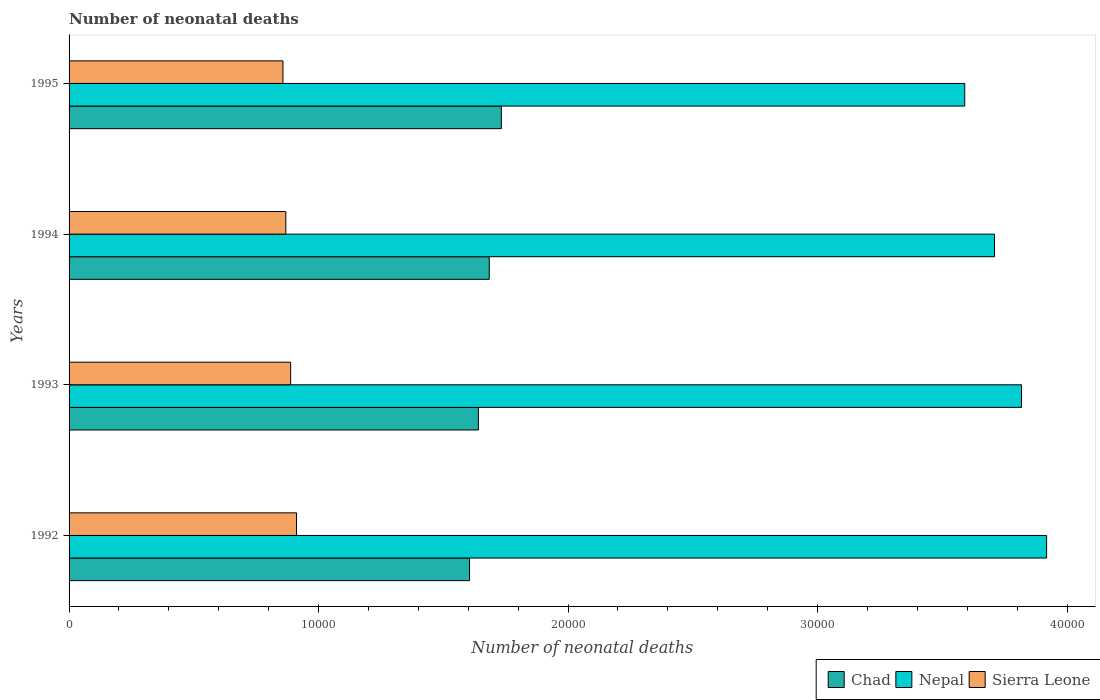How many different coloured bars are there?
Make the answer very short. 3. How many groups of bars are there?
Your answer should be very brief. 4. How many bars are there on the 4th tick from the top?
Provide a short and direct response. 3. In how many cases, is the number of bars for a given year not equal to the number of legend labels?
Your answer should be very brief. 0. What is the number of neonatal deaths in in Sierra Leone in 1993?
Give a very brief answer. 8881. Across all years, what is the maximum number of neonatal deaths in in Chad?
Make the answer very short. 1.73e+04. Across all years, what is the minimum number of neonatal deaths in in Chad?
Offer a very short reply. 1.60e+04. In which year was the number of neonatal deaths in in Sierra Leone maximum?
Give a very brief answer. 1992. What is the total number of neonatal deaths in in Nepal in the graph?
Ensure brevity in your answer.  1.50e+05. What is the difference between the number of neonatal deaths in in Nepal in 1992 and that in 1993?
Keep it short and to the point. 1006. What is the difference between the number of neonatal deaths in in Nepal in 1993 and the number of neonatal deaths in in Sierra Leone in 1995?
Your answer should be compact. 2.96e+04. What is the average number of neonatal deaths in in Chad per year?
Offer a very short reply. 1.67e+04. In the year 1992, what is the difference between the number of neonatal deaths in in Sierra Leone and number of neonatal deaths in in Nepal?
Provide a succinct answer. -3.01e+04. What is the ratio of the number of neonatal deaths in in Chad in 1992 to that in 1993?
Provide a succinct answer. 0.98. What is the difference between the highest and the second highest number of neonatal deaths in in Nepal?
Keep it short and to the point. 1006. What is the difference between the highest and the lowest number of neonatal deaths in in Chad?
Keep it short and to the point. 1275. In how many years, is the number of neonatal deaths in in Chad greater than the average number of neonatal deaths in in Chad taken over all years?
Your answer should be compact. 2. What does the 2nd bar from the top in 1993 represents?
Your response must be concise. Nepal. What does the 3rd bar from the bottom in 1993 represents?
Your response must be concise. Sierra Leone. Is it the case that in every year, the sum of the number of neonatal deaths in in Sierra Leone and number of neonatal deaths in in Chad is greater than the number of neonatal deaths in in Nepal?
Ensure brevity in your answer.  No. How many bars are there?
Provide a succinct answer. 12. Are all the bars in the graph horizontal?
Provide a succinct answer. Yes. How many years are there in the graph?
Give a very brief answer. 4. What is the difference between two consecutive major ticks on the X-axis?
Ensure brevity in your answer.  10000. Are the values on the major ticks of X-axis written in scientific E-notation?
Provide a short and direct response. No. Does the graph contain any zero values?
Offer a very short reply. No. Does the graph contain grids?
Your answer should be very brief. No. Where does the legend appear in the graph?
Your answer should be compact. Bottom right. How many legend labels are there?
Give a very brief answer. 3. How are the legend labels stacked?
Keep it short and to the point. Horizontal. What is the title of the graph?
Offer a very short reply. Number of neonatal deaths. What is the label or title of the X-axis?
Ensure brevity in your answer.  Number of neonatal deaths. What is the Number of neonatal deaths of Chad in 1992?
Your response must be concise. 1.60e+04. What is the Number of neonatal deaths in Nepal in 1992?
Keep it short and to the point. 3.92e+04. What is the Number of neonatal deaths in Sierra Leone in 1992?
Make the answer very short. 9116. What is the Number of neonatal deaths in Chad in 1993?
Your response must be concise. 1.64e+04. What is the Number of neonatal deaths in Nepal in 1993?
Ensure brevity in your answer.  3.82e+04. What is the Number of neonatal deaths in Sierra Leone in 1993?
Offer a very short reply. 8881. What is the Number of neonatal deaths in Chad in 1994?
Your answer should be very brief. 1.68e+04. What is the Number of neonatal deaths of Nepal in 1994?
Provide a succinct answer. 3.71e+04. What is the Number of neonatal deaths in Sierra Leone in 1994?
Your answer should be very brief. 8688. What is the Number of neonatal deaths in Chad in 1995?
Your response must be concise. 1.73e+04. What is the Number of neonatal deaths in Nepal in 1995?
Your answer should be very brief. 3.59e+04. What is the Number of neonatal deaths in Sierra Leone in 1995?
Keep it short and to the point. 8572. Across all years, what is the maximum Number of neonatal deaths in Chad?
Offer a terse response. 1.73e+04. Across all years, what is the maximum Number of neonatal deaths of Nepal?
Make the answer very short. 3.92e+04. Across all years, what is the maximum Number of neonatal deaths in Sierra Leone?
Provide a short and direct response. 9116. Across all years, what is the minimum Number of neonatal deaths of Chad?
Offer a very short reply. 1.60e+04. Across all years, what is the minimum Number of neonatal deaths in Nepal?
Give a very brief answer. 3.59e+04. Across all years, what is the minimum Number of neonatal deaths of Sierra Leone?
Provide a short and direct response. 8572. What is the total Number of neonatal deaths of Chad in the graph?
Keep it short and to the point. 6.66e+04. What is the total Number of neonatal deaths of Nepal in the graph?
Ensure brevity in your answer.  1.50e+05. What is the total Number of neonatal deaths of Sierra Leone in the graph?
Offer a very short reply. 3.53e+04. What is the difference between the Number of neonatal deaths in Chad in 1992 and that in 1993?
Provide a succinct answer. -355. What is the difference between the Number of neonatal deaths of Nepal in 1992 and that in 1993?
Provide a succinct answer. 1006. What is the difference between the Number of neonatal deaths in Sierra Leone in 1992 and that in 1993?
Offer a terse response. 235. What is the difference between the Number of neonatal deaths in Chad in 1992 and that in 1994?
Ensure brevity in your answer.  -791. What is the difference between the Number of neonatal deaths of Nepal in 1992 and that in 1994?
Your answer should be compact. 2089. What is the difference between the Number of neonatal deaths of Sierra Leone in 1992 and that in 1994?
Your answer should be very brief. 428. What is the difference between the Number of neonatal deaths of Chad in 1992 and that in 1995?
Keep it short and to the point. -1275. What is the difference between the Number of neonatal deaths of Nepal in 1992 and that in 1995?
Offer a terse response. 3282. What is the difference between the Number of neonatal deaths of Sierra Leone in 1992 and that in 1995?
Your answer should be compact. 544. What is the difference between the Number of neonatal deaths of Chad in 1993 and that in 1994?
Offer a terse response. -436. What is the difference between the Number of neonatal deaths in Nepal in 1993 and that in 1994?
Your answer should be compact. 1083. What is the difference between the Number of neonatal deaths in Sierra Leone in 1993 and that in 1994?
Your answer should be compact. 193. What is the difference between the Number of neonatal deaths in Chad in 1993 and that in 1995?
Your answer should be compact. -920. What is the difference between the Number of neonatal deaths of Nepal in 1993 and that in 1995?
Provide a succinct answer. 2276. What is the difference between the Number of neonatal deaths in Sierra Leone in 1993 and that in 1995?
Your answer should be compact. 309. What is the difference between the Number of neonatal deaths of Chad in 1994 and that in 1995?
Provide a short and direct response. -484. What is the difference between the Number of neonatal deaths of Nepal in 1994 and that in 1995?
Make the answer very short. 1193. What is the difference between the Number of neonatal deaths in Sierra Leone in 1994 and that in 1995?
Provide a succinct answer. 116. What is the difference between the Number of neonatal deaths in Chad in 1992 and the Number of neonatal deaths in Nepal in 1993?
Provide a succinct answer. -2.21e+04. What is the difference between the Number of neonatal deaths of Chad in 1992 and the Number of neonatal deaths of Sierra Leone in 1993?
Ensure brevity in your answer.  7169. What is the difference between the Number of neonatal deaths in Nepal in 1992 and the Number of neonatal deaths in Sierra Leone in 1993?
Keep it short and to the point. 3.03e+04. What is the difference between the Number of neonatal deaths in Chad in 1992 and the Number of neonatal deaths in Nepal in 1994?
Your response must be concise. -2.10e+04. What is the difference between the Number of neonatal deaths of Chad in 1992 and the Number of neonatal deaths of Sierra Leone in 1994?
Keep it short and to the point. 7362. What is the difference between the Number of neonatal deaths of Nepal in 1992 and the Number of neonatal deaths of Sierra Leone in 1994?
Make the answer very short. 3.05e+04. What is the difference between the Number of neonatal deaths in Chad in 1992 and the Number of neonatal deaths in Nepal in 1995?
Your response must be concise. -1.98e+04. What is the difference between the Number of neonatal deaths of Chad in 1992 and the Number of neonatal deaths of Sierra Leone in 1995?
Ensure brevity in your answer.  7478. What is the difference between the Number of neonatal deaths in Nepal in 1992 and the Number of neonatal deaths in Sierra Leone in 1995?
Offer a very short reply. 3.06e+04. What is the difference between the Number of neonatal deaths of Chad in 1993 and the Number of neonatal deaths of Nepal in 1994?
Make the answer very short. -2.07e+04. What is the difference between the Number of neonatal deaths of Chad in 1993 and the Number of neonatal deaths of Sierra Leone in 1994?
Provide a short and direct response. 7717. What is the difference between the Number of neonatal deaths in Nepal in 1993 and the Number of neonatal deaths in Sierra Leone in 1994?
Ensure brevity in your answer.  2.95e+04. What is the difference between the Number of neonatal deaths of Chad in 1993 and the Number of neonatal deaths of Nepal in 1995?
Ensure brevity in your answer.  -1.95e+04. What is the difference between the Number of neonatal deaths of Chad in 1993 and the Number of neonatal deaths of Sierra Leone in 1995?
Make the answer very short. 7833. What is the difference between the Number of neonatal deaths in Nepal in 1993 and the Number of neonatal deaths in Sierra Leone in 1995?
Give a very brief answer. 2.96e+04. What is the difference between the Number of neonatal deaths of Chad in 1994 and the Number of neonatal deaths of Nepal in 1995?
Keep it short and to the point. -1.91e+04. What is the difference between the Number of neonatal deaths of Chad in 1994 and the Number of neonatal deaths of Sierra Leone in 1995?
Your answer should be compact. 8269. What is the difference between the Number of neonatal deaths of Nepal in 1994 and the Number of neonatal deaths of Sierra Leone in 1995?
Your response must be concise. 2.85e+04. What is the average Number of neonatal deaths of Chad per year?
Your answer should be very brief. 1.67e+04. What is the average Number of neonatal deaths of Nepal per year?
Provide a succinct answer. 3.76e+04. What is the average Number of neonatal deaths in Sierra Leone per year?
Ensure brevity in your answer.  8814.25. In the year 1992, what is the difference between the Number of neonatal deaths of Chad and Number of neonatal deaths of Nepal?
Ensure brevity in your answer.  -2.31e+04. In the year 1992, what is the difference between the Number of neonatal deaths in Chad and Number of neonatal deaths in Sierra Leone?
Keep it short and to the point. 6934. In the year 1992, what is the difference between the Number of neonatal deaths of Nepal and Number of neonatal deaths of Sierra Leone?
Ensure brevity in your answer.  3.01e+04. In the year 1993, what is the difference between the Number of neonatal deaths of Chad and Number of neonatal deaths of Nepal?
Keep it short and to the point. -2.18e+04. In the year 1993, what is the difference between the Number of neonatal deaths in Chad and Number of neonatal deaths in Sierra Leone?
Provide a short and direct response. 7524. In the year 1993, what is the difference between the Number of neonatal deaths in Nepal and Number of neonatal deaths in Sierra Leone?
Give a very brief answer. 2.93e+04. In the year 1994, what is the difference between the Number of neonatal deaths of Chad and Number of neonatal deaths of Nepal?
Offer a very short reply. -2.02e+04. In the year 1994, what is the difference between the Number of neonatal deaths in Chad and Number of neonatal deaths in Sierra Leone?
Provide a succinct answer. 8153. In the year 1994, what is the difference between the Number of neonatal deaths of Nepal and Number of neonatal deaths of Sierra Leone?
Keep it short and to the point. 2.84e+04. In the year 1995, what is the difference between the Number of neonatal deaths of Chad and Number of neonatal deaths of Nepal?
Your response must be concise. -1.86e+04. In the year 1995, what is the difference between the Number of neonatal deaths of Chad and Number of neonatal deaths of Sierra Leone?
Give a very brief answer. 8753. In the year 1995, what is the difference between the Number of neonatal deaths in Nepal and Number of neonatal deaths in Sierra Leone?
Keep it short and to the point. 2.73e+04. What is the ratio of the Number of neonatal deaths in Chad in 1992 to that in 1993?
Provide a succinct answer. 0.98. What is the ratio of the Number of neonatal deaths of Nepal in 1992 to that in 1993?
Your answer should be very brief. 1.03. What is the ratio of the Number of neonatal deaths of Sierra Leone in 1992 to that in 1993?
Provide a succinct answer. 1.03. What is the ratio of the Number of neonatal deaths in Chad in 1992 to that in 1994?
Give a very brief answer. 0.95. What is the ratio of the Number of neonatal deaths of Nepal in 1992 to that in 1994?
Ensure brevity in your answer.  1.06. What is the ratio of the Number of neonatal deaths in Sierra Leone in 1992 to that in 1994?
Ensure brevity in your answer.  1.05. What is the ratio of the Number of neonatal deaths in Chad in 1992 to that in 1995?
Offer a terse response. 0.93. What is the ratio of the Number of neonatal deaths of Nepal in 1992 to that in 1995?
Your answer should be compact. 1.09. What is the ratio of the Number of neonatal deaths of Sierra Leone in 1992 to that in 1995?
Make the answer very short. 1.06. What is the ratio of the Number of neonatal deaths of Chad in 1993 to that in 1994?
Give a very brief answer. 0.97. What is the ratio of the Number of neonatal deaths of Nepal in 1993 to that in 1994?
Your answer should be very brief. 1.03. What is the ratio of the Number of neonatal deaths of Sierra Leone in 1993 to that in 1994?
Your answer should be very brief. 1.02. What is the ratio of the Number of neonatal deaths of Chad in 1993 to that in 1995?
Offer a terse response. 0.95. What is the ratio of the Number of neonatal deaths in Nepal in 1993 to that in 1995?
Give a very brief answer. 1.06. What is the ratio of the Number of neonatal deaths in Sierra Leone in 1993 to that in 1995?
Give a very brief answer. 1.04. What is the ratio of the Number of neonatal deaths of Chad in 1994 to that in 1995?
Make the answer very short. 0.97. What is the ratio of the Number of neonatal deaths in Nepal in 1994 to that in 1995?
Offer a very short reply. 1.03. What is the ratio of the Number of neonatal deaths in Sierra Leone in 1994 to that in 1995?
Offer a terse response. 1.01. What is the difference between the highest and the second highest Number of neonatal deaths of Chad?
Provide a succinct answer. 484. What is the difference between the highest and the second highest Number of neonatal deaths in Nepal?
Offer a terse response. 1006. What is the difference between the highest and the second highest Number of neonatal deaths of Sierra Leone?
Offer a terse response. 235. What is the difference between the highest and the lowest Number of neonatal deaths of Chad?
Your response must be concise. 1275. What is the difference between the highest and the lowest Number of neonatal deaths of Nepal?
Provide a succinct answer. 3282. What is the difference between the highest and the lowest Number of neonatal deaths in Sierra Leone?
Give a very brief answer. 544. 